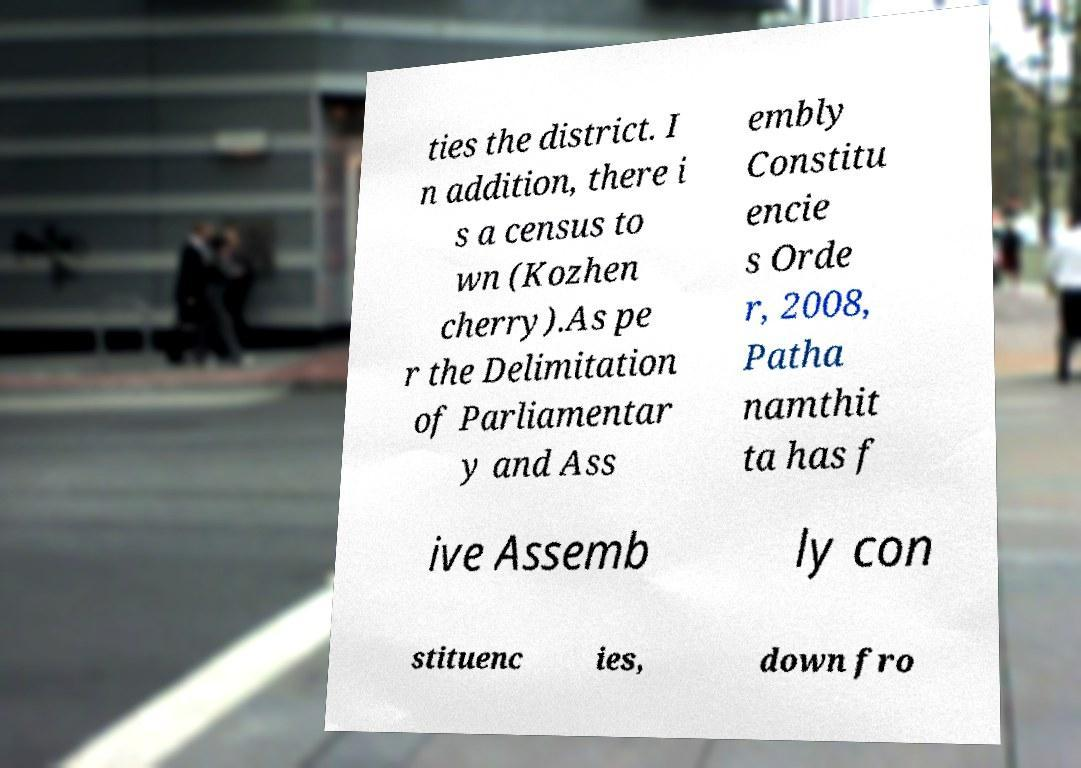Could you extract and type out the text from this image? ties the district. I n addition, there i s a census to wn (Kozhen cherry).As pe r the Delimitation of Parliamentar y and Ass embly Constitu encie s Orde r, 2008, Patha namthit ta has f ive Assemb ly con stituenc ies, down fro 